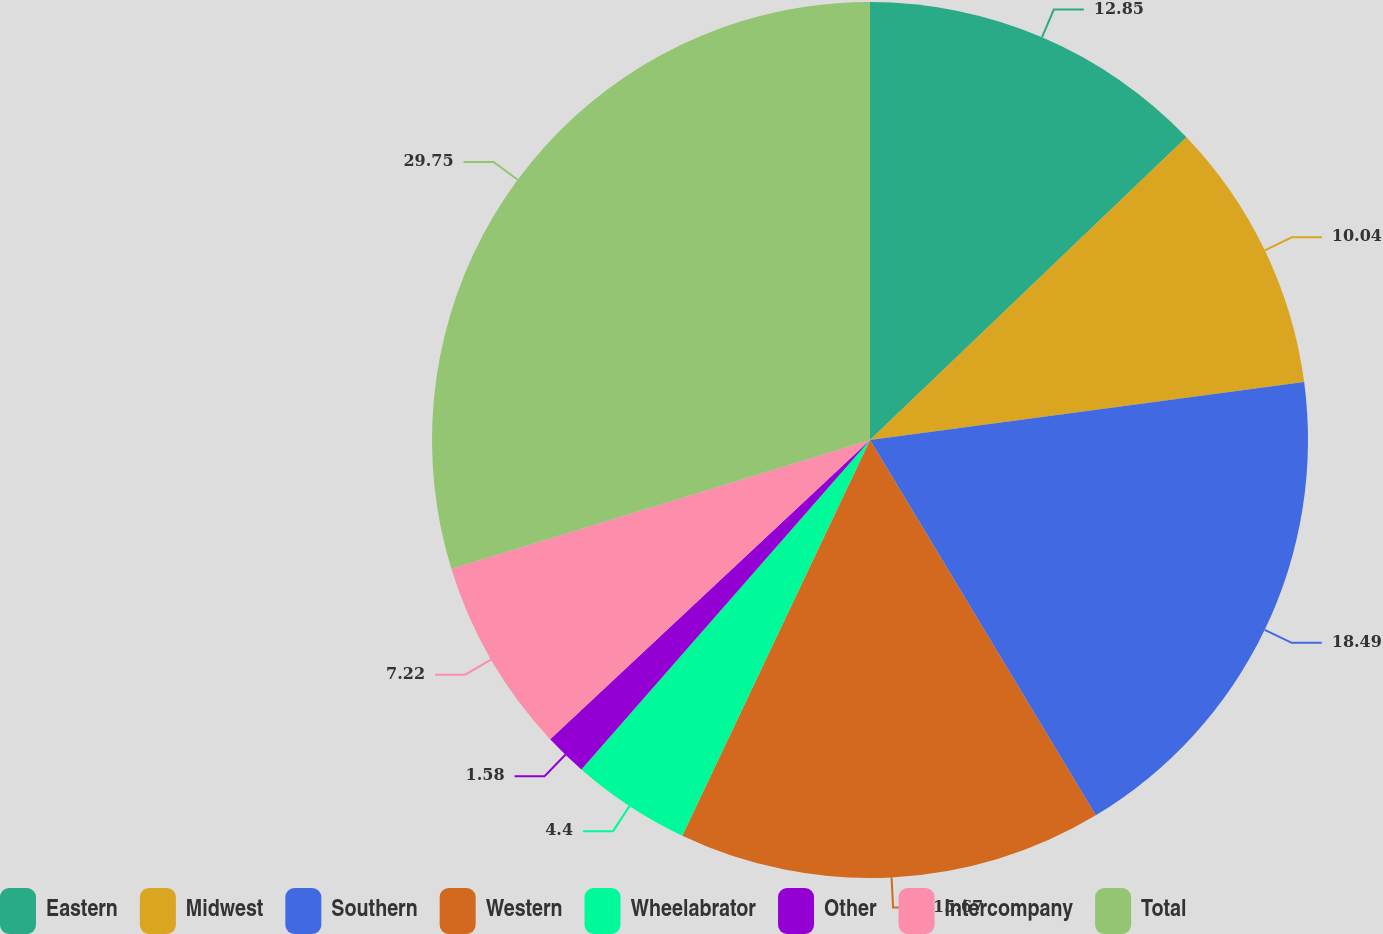Convert chart. <chart><loc_0><loc_0><loc_500><loc_500><pie_chart><fcel>Eastern<fcel>Midwest<fcel>Southern<fcel>Western<fcel>Wheelabrator<fcel>Other<fcel>Intercompany<fcel>Total<nl><fcel>12.85%<fcel>10.04%<fcel>18.49%<fcel>15.67%<fcel>4.4%<fcel>1.58%<fcel>7.22%<fcel>29.75%<nl></chart> 